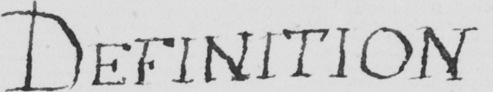Transcribe the text shown in this historical manuscript line. DEFINITION 